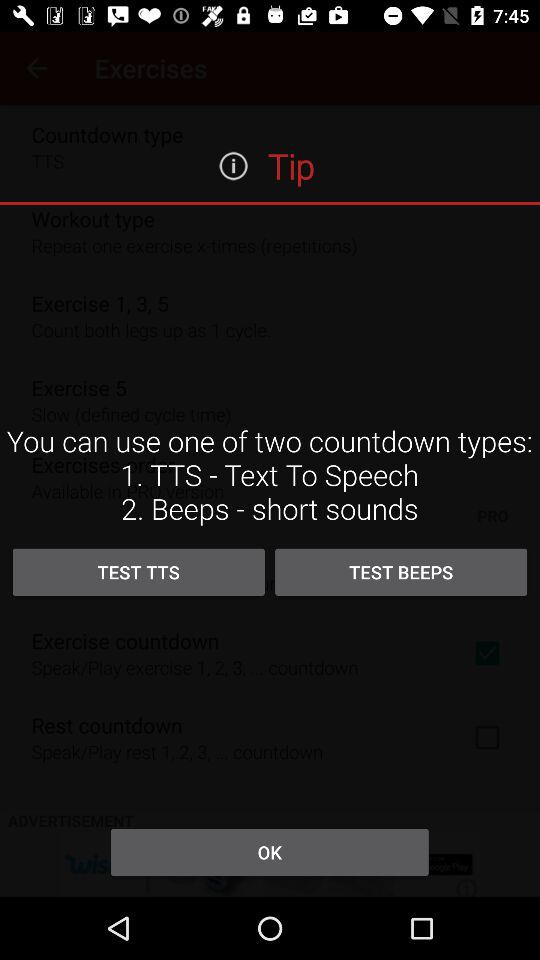What are the two countdown types? The two countdown types are "TTS - Text To Speech" and "Beeps - short sounds". 